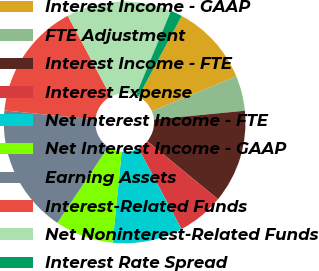Convert chart. <chart><loc_0><loc_0><loc_500><loc_500><pie_chart><fcel>Interest Income - GAAP<fcel>FTE Adjustment<fcel>Interest Income - FTE<fcel>Interest Expense<fcel>Net Interest Income - FTE<fcel>Net Interest Income - GAAP<fcel>Earning Assets<fcel>Interest-Related Funds<fcel>Net Noninterest-Related Funds<fcel>Interest Rate Spread<nl><fcel>10.94%<fcel>4.69%<fcel>12.5%<fcel>6.25%<fcel>9.38%<fcel>7.81%<fcel>17.19%<fcel>15.62%<fcel>14.06%<fcel>1.56%<nl></chart> 